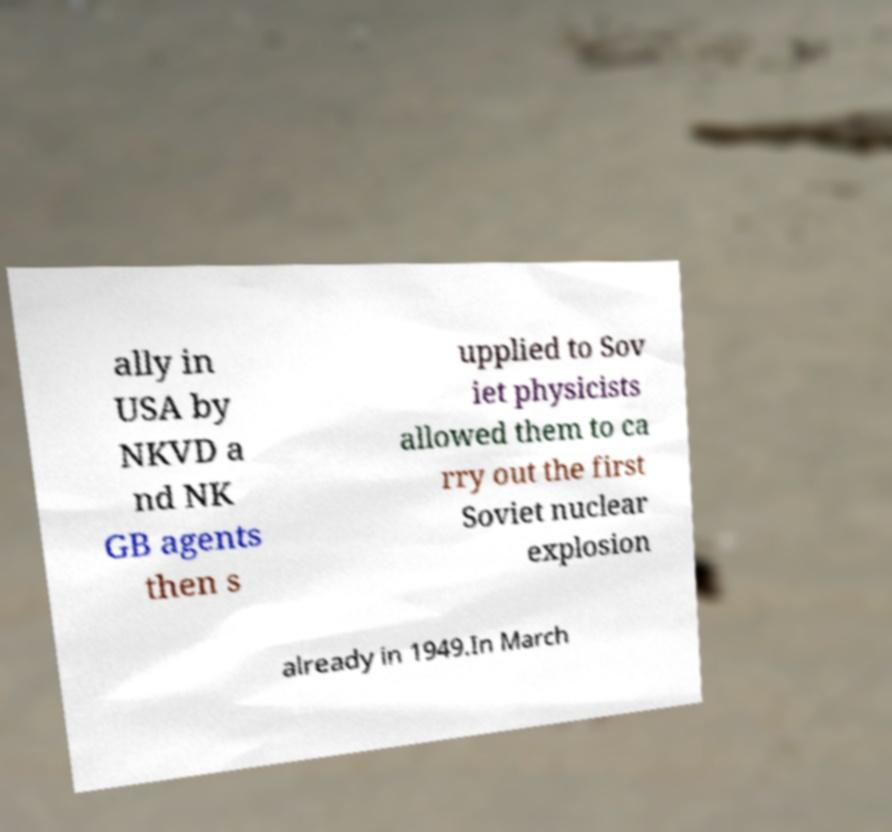For documentation purposes, I need the text within this image transcribed. Could you provide that? ally in USA by NKVD a nd NK GB agents then s upplied to Sov iet physicists allowed them to ca rry out the first Soviet nuclear explosion already in 1949.In March 